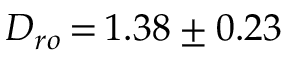Convert formula to latex. <formula><loc_0><loc_0><loc_500><loc_500>D _ { r o } \, { = } \, 1 . 3 8 \pm 0 . 2 3</formula> 